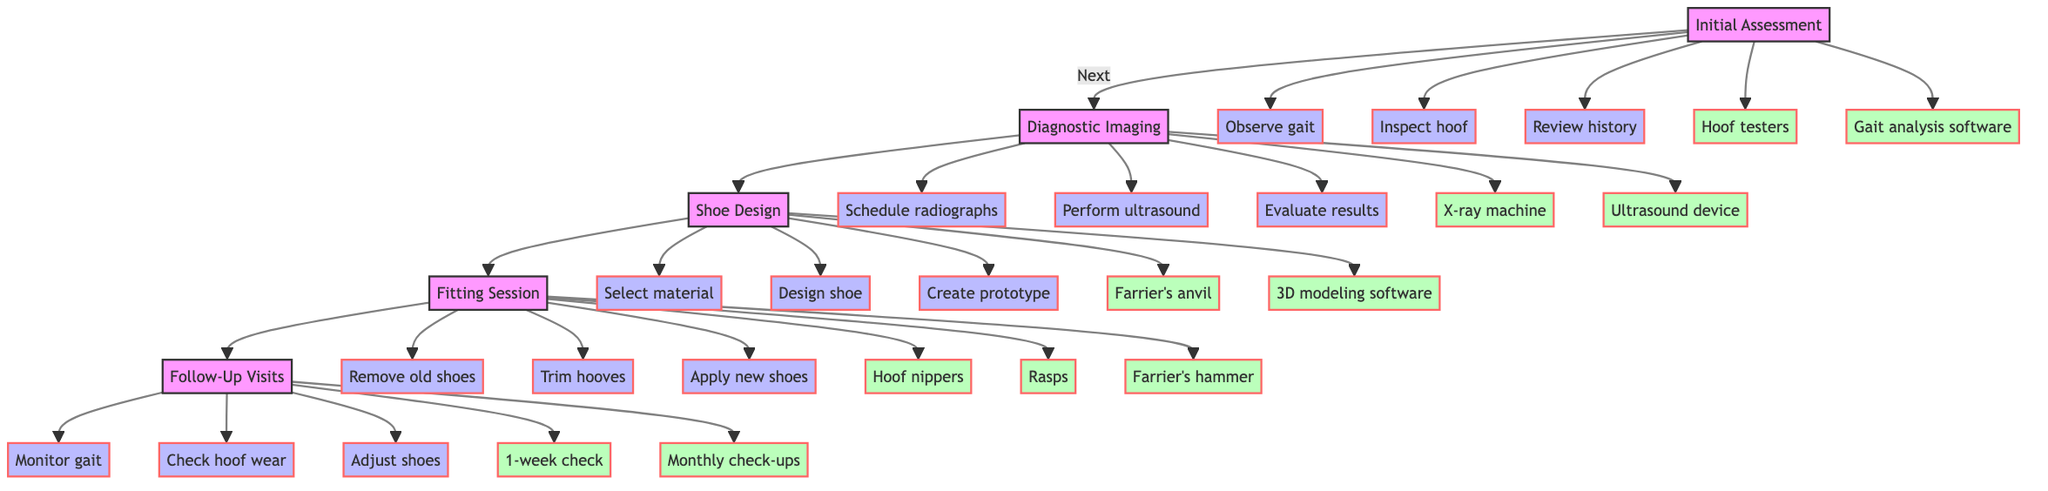What is the first step in the pathway? The first step in the pathway is "Initial Assessment," where the process begins.
Answer: Initial Assessment How many steps are involved in the Diagnostic Imaging phase? The Diagnostic Imaging phase has three steps: schedule radiographs, perform ultrasound if needed, and evaluate imaging results.
Answer: 3 What tool is used in the Shoe Design step? The tool used in the Shoe Design step is "3D modeling software," which helps to create shoe prototypes.
Answer: 3D modeling software What follows after the Fitting Session? After the Fitting Session, the next step is "Follow-Up Visits," where the horse's condition will be monitored.
Answer: Follow-Up Visits Which step involves trimming and balancing hooves? The step that involves trimming and balancing hooves is the "Fitting Session," where old shoes are removed and new shoes are applied.
Answer: Fitting Session How many total steps are there in the entire clinical pathway? The entire clinical pathway includes a total of 15 steps across all phases: 3 in Initial Assessment, 3 in Diagnostic Imaging, 3 in Shoe Design, 3 in Fitting Session, and 3 in Follow-Up Visits.
Answer: 15 What is the purpose of the Follow-Up Visits? The purpose of the Follow-Up Visits is to monitor the horse's gait for improvements and check for any hoof wear or damage.
Answer: Monitor gait In which phase will you apply custom-designed horseshoes? Custom-designed horseshoes are applied during the "Fitting Session," which is specifically focused on that task.
Answer: Fitting Session What actions are taken during the Follow-Up Visits? During Follow-Up Visits, actions taken include monitoring gait for improvements, checking for hoof wear or damage, and adjusting or replacing shoes as needed.
Answer: Monitoring gait, checking wear, adjusting shoes 